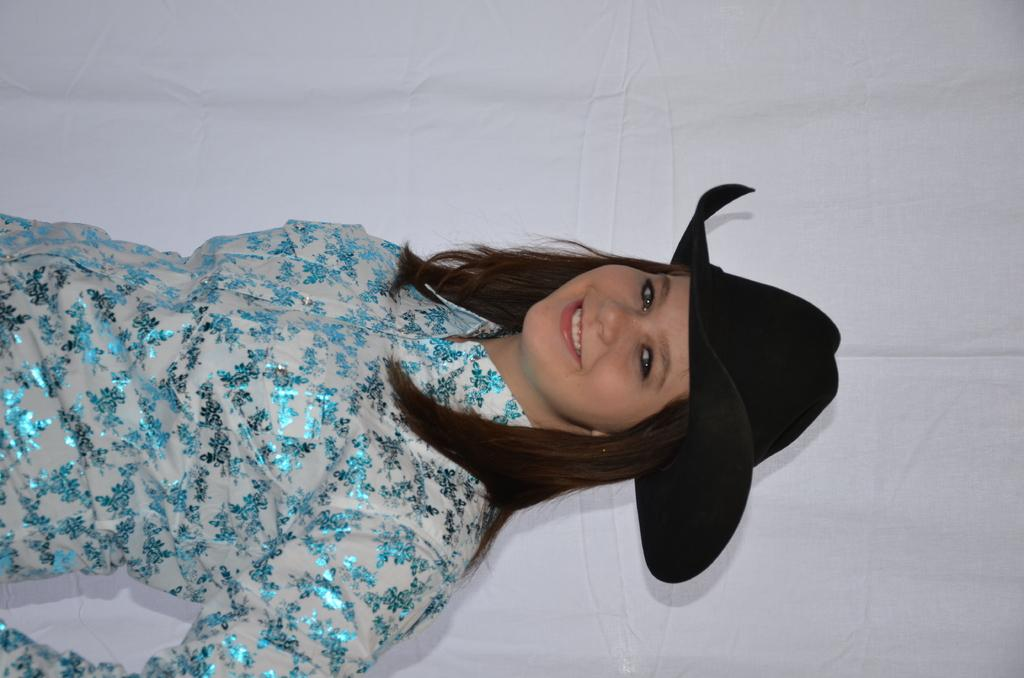Who is the main subject in the image? There is a woman in the image. What is the woman wearing on her head? The woman is wearing a black hat. What is the woman's facial expression in the image? The woman is smiling. What is the color of the background in the image? The background in the image is white. Can you see any quivering in the woman's hands in the image? There is no indication of quivering in the woman's hands in the image. Does the woman appear to be feeling any shame in the image? There is no indication of shame in the woman's facial expression or body language in the image. 